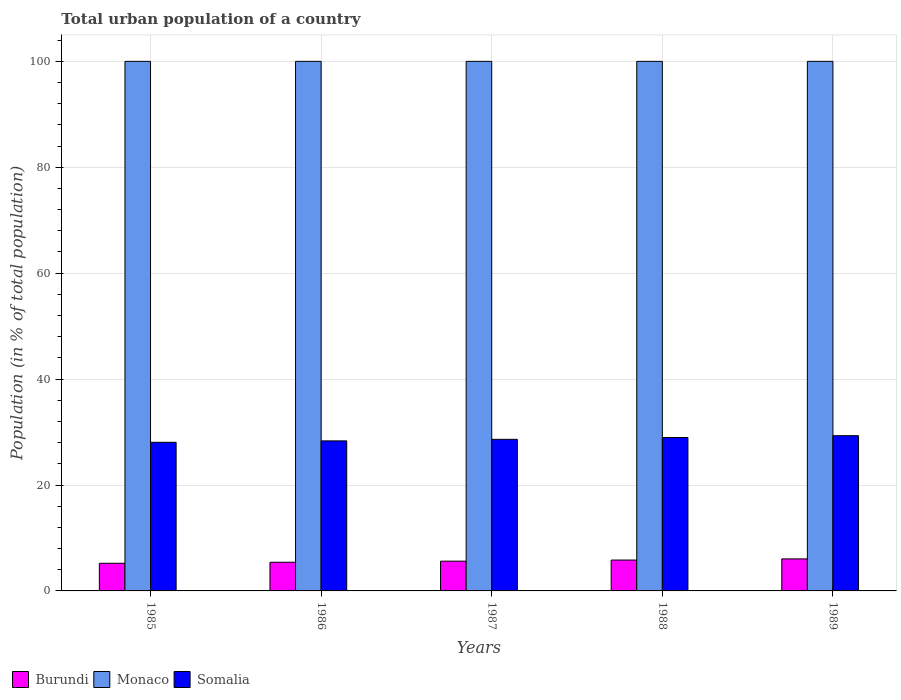Are the number of bars per tick equal to the number of legend labels?
Your answer should be very brief. Yes. Are the number of bars on each tick of the X-axis equal?
Keep it short and to the point. Yes. How many bars are there on the 1st tick from the left?
Ensure brevity in your answer.  3. How many bars are there on the 5th tick from the right?
Ensure brevity in your answer.  3. What is the label of the 1st group of bars from the left?
Make the answer very short. 1985. In how many cases, is the number of bars for a given year not equal to the number of legend labels?
Your answer should be compact. 0. What is the urban population in Monaco in 1989?
Offer a very short reply. 100. Across all years, what is the maximum urban population in Burundi?
Offer a very short reply. 6.05. Across all years, what is the minimum urban population in Monaco?
Ensure brevity in your answer.  100. What is the total urban population in Monaco in the graph?
Your response must be concise. 500. What is the difference between the urban population in Monaco in 1985 and that in 1989?
Provide a succinct answer. 0. What is the difference between the urban population in Somalia in 1986 and the urban population in Monaco in 1988?
Your answer should be very brief. -71.67. What is the average urban population in Somalia per year?
Your answer should be very brief. 28.66. In the year 1988, what is the difference between the urban population in Burundi and urban population in Monaco?
Your answer should be very brief. -94.17. In how many years, is the urban population in Monaco greater than 28 %?
Offer a terse response. 5. What is the ratio of the urban population in Burundi in 1988 to that in 1989?
Give a very brief answer. 0.96. Is the urban population in Monaco in 1987 less than that in 1989?
Give a very brief answer. No. What is the difference between the highest and the second highest urban population in Somalia?
Ensure brevity in your answer.  0.34. What is the difference between the highest and the lowest urban population in Burundi?
Keep it short and to the point. 0.83. Is the sum of the urban population in Somalia in 1985 and 1989 greater than the maximum urban population in Monaco across all years?
Make the answer very short. No. What does the 1st bar from the left in 1986 represents?
Your answer should be compact. Burundi. What does the 3rd bar from the right in 1985 represents?
Make the answer very short. Burundi. What is the difference between two consecutive major ticks on the Y-axis?
Provide a succinct answer. 20. Does the graph contain grids?
Give a very brief answer. Yes. How many legend labels are there?
Offer a terse response. 3. How are the legend labels stacked?
Make the answer very short. Horizontal. What is the title of the graph?
Provide a short and direct response. Total urban population of a country. Does "Northern Mariana Islands" appear as one of the legend labels in the graph?
Give a very brief answer. No. What is the label or title of the X-axis?
Your answer should be compact. Years. What is the label or title of the Y-axis?
Your answer should be very brief. Population (in % of total population). What is the Population (in % of total population) in Burundi in 1985?
Provide a succinct answer. 5.22. What is the Population (in % of total population) in Monaco in 1985?
Provide a succinct answer. 100. What is the Population (in % of total population) of Somalia in 1985?
Your response must be concise. 28.07. What is the Population (in % of total population) of Burundi in 1986?
Your answer should be compact. 5.42. What is the Population (in % of total population) in Somalia in 1986?
Provide a succinct answer. 28.33. What is the Population (in % of total population) of Burundi in 1987?
Offer a terse response. 5.62. What is the Population (in % of total population) of Monaco in 1987?
Offer a terse response. 100. What is the Population (in % of total population) in Somalia in 1987?
Keep it short and to the point. 28.63. What is the Population (in % of total population) in Burundi in 1988?
Provide a short and direct response. 5.83. What is the Population (in % of total population) in Monaco in 1988?
Your answer should be compact. 100. What is the Population (in % of total population) of Somalia in 1988?
Offer a terse response. 28.97. What is the Population (in % of total population) of Burundi in 1989?
Your answer should be very brief. 6.05. What is the Population (in % of total population) in Monaco in 1989?
Offer a terse response. 100. What is the Population (in % of total population) in Somalia in 1989?
Your response must be concise. 29.31. Across all years, what is the maximum Population (in % of total population) of Burundi?
Keep it short and to the point. 6.05. Across all years, what is the maximum Population (in % of total population) of Monaco?
Provide a short and direct response. 100. Across all years, what is the maximum Population (in % of total population) of Somalia?
Your response must be concise. 29.31. Across all years, what is the minimum Population (in % of total population) of Burundi?
Your answer should be very brief. 5.22. Across all years, what is the minimum Population (in % of total population) of Monaco?
Offer a very short reply. 100. Across all years, what is the minimum Population (in % of total population) of Somalia?
Make the answer very short. 28.07. What is the total Population (in % of total population) in Burundi in the graph?
Provide a succinct answer. 28.14. What is the total Population (in % of total population) of Monaco in the graph?
Offer a terse response. 500. What is the total Population (in % of total population) of Somalia in the graph?
Offer a very short reply. 143.31. What is the difference between the Population (in % of total population) in Burundi in 1985 and that in 1986?
Your answer should be very brief. -0.2. What is the difference between the Population (in % of total population) of Somalia in 1985 and that in 1986?
Your answer should be very brief. -0.27. What is the difference between the Population (in % of total population) of Burundi in 1985 and that in 1987?
Offer a very short reply. -0.4. What is the difference between the Population (in % of total population) in Somalia in 1985 and that in 1987?
Offer a terse response. -0.56. What is the difference between the Population (in % of total population) of Burundi in 1985 and that in 1988?
Offer a terse response. -0.61. What is the difference between the Population (in % of total population) in Somalia in 1985 and that in 1988?
Keep it short and to the point. -0.9. What is the difference between the Population (in % of total population) of Burundi in 1985 and that in 1989?
Make the answer very short. -0.83. What is the difference between the Population (in % of total population) of Monaco in 1985 and that in 1989?
Keep it short and to the point. 0. What is the difference between the Population (in % of total population) in Somalia in 1985 and that in 1989?
Offer a terse response. -1.25. What is the difference between the Population (in % of total population) of Burundi in 1986 and that in 1987?
Your answer should be very brief. -0.2. What is the difference between the Population (in % of total population) of Monaco in 1986 and that in 1987?
Provide a succinct answer. 0. What is the difference between the Population (in % of total population) of Somalia in 1986 and that in 1987?
Offer a very short reply. -0.29. What is the difference between the Population (in % of total population) in Burundi in 1986 and that in 1988?
Your answer should be very brief. -0.41. What is the difference between the Population (in % of total population) in Monaco in 1986 and that in 1988?
Make the answer very short. 0. What is the difference between the Population (in % of total population) in Somalia in 1986 and that in 1988?
Ensure brevity in your answer.  -0.64. What is the difference between the Population (in % of total population) in Burundi in 1986 and that in 1989?
Your response must be concise. -0.63. What is the difference between the Population (in % of total population) in Monaco in 1986 and that in 1989?
Your answer should be compact. 0. What is the difference between the Population (in % of total population) in Somalia in 1986 and that in 1989?
Offer a terse response. -0.98. What is the difference between the Population (in % of total population) of Burundi in 1987 and that in 1988?
Make the answer very short. -0.21. What is the difference between the Population (in % of total population) in Monaco in 1987 and that in 1988?
Provide a succinct answer. 0. What is the difference between the Population (in % of total population) in Somalia in 1987 and that in 1988?
Your response must be concise. -0.34. What is the difference between the Population (in % of total population) of Burundi in 1987 and that in 1989?
Offer a very short reply. -0.43. What is the difference between the Population (in % of total population) in Somalia in 1987 and that in 1989?
Your response must be concise. -0.69. What is the difference between the Population (in % of total population) of Burundi in 1988 and that in 1989?
Ensure brevity in your answer.  -0.22. What is the difference between the Population (in % of total population) of Somalia in 1988 and that in 1989?
Your answer should be compact. -0.34. What is the difference between the Population (in % of total population) in Burundi in 1985 and the Population (in % of total population) in Monaco in 1986?
Offer a terse response. -94.78. What is the difference between the Population (in % of total population) in Burundi in 1985 and the Population (in % of total population) in Somalia in 1986?
Your answer should be compact. -23.11. What is the difference between the Population (in % of total population) of Monaco in 1985 and the Population (in % of total population) of Somalia in 1986?
Your answer should be very brief. 71.67. What is the difference between the Population (in % of total population) of Burundi in 1985 and the Population (in % of total population) of Monaco in 1987?
Your answer should be compact. -94.78. What is the difference between the Population (in % of total population) in Burundi in 1985 and the Population (in % of total population) in Somalia in 1987?
Offer a very short reply. -23.41. What is the difference between the Population (in % of total population) of Monaco in 1985 and the Population (in % of total population) of Somalia in 1987?
Offer a very short reply. 71.37. What is the difference between the Population (in % of total population) in Burundi in 1985 and the Population (in % of total population) in Monaco in 1988?
Ensure brevity in your answer.  -94.78. What is the difference between the Population (in % of total population) in Burundi in 1985 and the Population (in % of total population) in Somalia in 1988?
Your answer should be very brief. -23.75. What is the difference between the Population (in % of total population) of Monaco in 1985 and the Population (in % of total population) of Somalia in 1988?
Your answer should be very brief. 71.03. What is the difference between the Population (in % of total population) of Burundi in 1985 and the Population (in % of total population) of Monaco in 1989?
Keep it short and to the point. -94.78. What is the difference between the Population (in % of total population) of Burundi in 1985 and the Population (in % of total population) of Somalia in 1989?
Give a very brief answer. -24.09. What is the difference between the Population (in % of total population) of Monaco in 1985 and the Population (in % of total population) of Somalia in 1989?
Offer a very short reply. 70.69. What is the difference between the Population (in % of total population) in Burundi in 1986 and the Population (in % of total population) in Monaco in 1987?
Offer a very short reply. -94.58. What is the difference between the Population (in % of total population) in Burundi in 1986 and the Population (in % of total population) in Somalia in 1987?
Provide a succinct answer. -23.21. What is the difference between the Population (in % of total population) of Monaco in 1986 and the Population (in % of total population) of Somalia in 1987?
Make the answer very short. 71.37. What is the difference between the Population (in % of total population) in Burundi in 1986 and the Population (in % of total population) in Monaco in 1988?
Offer a terse response. -94.58. What is the difference between the Population (in % of total population) of Burundi in 1986 and the Population (in % of total population) of Somalia in 1988?
Offer a very short reply. -23.55. What is the difference between the Population (in % of total population) in Monaco in 1986 and the Population (in % of total population) in Somalia in 1988?
Offer a very short reply. 71.03. What is the difference between the Population (in % of total population) of Burundi in 1986 and the Population (in % of total population) of Monaco in 1989?
Your response must be concise. -94.58. What is the difference between the Population (in % of total population) in Burundi in 1986 and the Population (in % of total population) in Somalia in 1989?
Provide a short and direct response. -23.89. What is the difference between the Population (in % of total population) of Monaco in 1986 and the Population (in % of total population) of Somalia in 1989?
Offer a terse response. 70.69. What is the difference between the Population (in % of total population) in Burundi in 1987 and the Population (in % of total population) in Monaco in 1988?
Your response must be concise. -94.38. What is the difference between the Population (in % of total population) in Burundi in 1987 and the Population (in % of total population) in Somalia in 1988?
Ensure brevity in your answer.  -23.35. What is the difference between the Population (in % of total population) of Monaco in 1987 and the Population (in % of total population) of Somalia in 1988?
Your answer should be compact. 71.03. What is the difference between the Population (in % of total population) in Burundi in 1987 and the Population (in % of total population) in Monaco in 1989?
Offer a very short reply. -94.38. What is the difference between the Population (in % of total population) in Burundi in 1987 and the Population (in % of total population) in Somalia in 1989?
Provide a short and direct response. -23.69. What is the difference between the Population (in % of total population) in Monaco in 1987 and the Population (in % of total population) in Somalia in 1989?
Your answer should be very brief. 70.69. What is the difference between the Population (in % of total population) in Burundi in 1988 and the Population (in % of total population) in Monaco in 1989?
Your answer should be very brief. -94.17. What is the difference between the Population (in % of total population) in Burundi in 1988 and the Population (in % of total population) in Somalia in 1989?
Your response must be concise. -23.48. What is the difference between the Population (in % of total population) in Monaco in 1988 and the Population (in % of total population) in Somalia in 1989?
Offer a very short reply. 70.69. What is the average Population (in % of total population) in Burundi per year?
Provide a succinct answer. 5.63. What is the average Population (in % of total population) in Somalia per year?
Ensure brevity in your answer.  28.66. In the year 1985, what is the difference between the Population (in % of total population) in Burundi and Population (in % of total population) in Monaco?
Give a very brief answer. -94.78. In the year 1985, what is the difference between the Population (in % of total population) in Burundi and Population (in % of total population) in Somalia?
Give a very brief answer. -22.85. In the year 1985, what is the difference between the Population (in % of total population) of Monaco and Population (in % of total population) of Somalia?
Make the answer very short. 71.93. In the year 1986, what is the difference between the Population (in % of total population) in Burundi and Population (in % of total population) in Monaco?
Provide a short and direct response. -94.58. In the year 1986, what is the difference between the Population (in % of total population) in Burundi and Population (in % of total population) in Somalia?
Your response must be concise. -22.92. In the year 1986, what is the difference between the Population (in % of total population) of Monaco and Population (in % of total population) of Somalia?
Give a very brief answer. 71.67. In the year 1987, what is the difference between the Population (in % of total population) in Burundi and Population (in % of total population) in Monaco?
Keep it short and to the point. -94.38. In the year 1987, what is the difference between the Population (in % of total population) in Burundi and Population (in % of total population) in Somalia?
Provide a succinct answer. -23.01. In the year 1987, what is the difference between the Population (in % of total population) of Monaco and Population (in % of total population) of Somalia?
Make the answer very short. 71.37. In the year 1988, what is the difference between the Population (in % of total population) of Burundi and Population (in % of total population) of Monaco?
Your answer should be very brief. -94.17. In the year 1988, what is the difference between the Population (in % of total population) in Burundi and Population (in % of total population) in Somalia?
Ensure brevity in your answer.  -23.14. In the year 1988, what is the difference between the Population (in % of total population) in Monaco and Population (in % of total population) in Somalia?
Provide a succinct answer. 71.03. In the year 1989, what is the difference between the Population (in % of total population) in Burundi and Population (in % of total population) in Monaco?
Provide a succinct answer. -93.95. In the year 1989, what is the difference between the Population (in % of total population) of Burundi and Population (in % of total population) of Somalia?
Your response must be concise. -23.27. In the year 1989, what is the difference between the Population (in % of total population) in Monaco and Population (in % of total population) in Somalia?
Make the answer very short. 70.69. What is the ratio of the Population (in % of total population) in Burundi in 1985 to that in 1986?
Offer a terse response. 0.96. What is the ratio of the Population (in % of total population) in Monaco in 1985 to that in 1986?
Keep it short and to the point. 1. What is the ratio of the Population (in % of total population) in Somalia in 1985 to that in 1986?
Your answer should be compact. 0.99. What is the ratio of the Population (in % of total population) in Burundi in 1985 to that in 1987?
Offer a very short reply. 0.93. What is the ratio of the Population (in % of total population) in Somalia in 1985 to that in 1987?
Offer a terse response. 0.98. What is the ratio of the Population (in % of total population) of Burundi in 1985 to that in 1988?
Your answer should be very brief. 0.9. What is the ratio of the Population (in % of total population) in Monaco in 1985 to that in 1988?
Your answer should be very brief. 1. What is the ratio of the Population (in % of total population) in Somalia in 1985 to that in 1988?
Make the answer very short. 0.97. What is the ratio of the Population (in % of total population) in Burundi in 1985 to that in 1989?
Your answer should be compact. 0.86. What is the ratio of the Population (in % of total population) in Somalia in 1985 to that in 1989?
Provide a short and direct response. 0.96. What is the ratio of the Population (in % of total population) of Burundi in 1986 to that in 1987?
Make the answer very short. 0.96. What is the ratio of the Population (in % of total population) of Somalia in 1986 to that in 1987?
Your answer should be compact. 0.99. What is the ratio of the Population (in % of total population) of Burundi in 1986 to that in 1988?
Ensure brevity in your answer.  0.93. What is the ratio of the Population (in % of total population) in Monaco in 1986 to that in 1988?
Provide a succinct answer. 1. What is the ratio of the Population (in % of total population) of Burundi in 1986 to that in 1989?
Your answer should be very brief. 0.9. What is the ratio of the Population (in % of total population) of Monaco in 1986 to that in 1989?
Keep it short and to the point. 1. What is the ratio of the Population (in % of total population) in Somalia in 1986 to that in 1989?
Your answer should be very brief. 0.97. What is the ratio of the Population (in % of total population) of Monaco in 1987 to that in 1988?
Your answer should be compact. 1. What is the ratio of the Population (in % of total population) of Burundi in 1987 to that in 1989?
Your answer should be compact. 0.93. What is the ratio of the Population (in % of total population) in Somalia in 1987 to that in 1989?
Your answer should be very brief. 0.98. What is the ratio of the Population (in % of total population) of Burundi in 1988 to that in 1989?
Offer a terse response. 0.96. What is the ratio of the Population (in % of total population) of Monaco in 1988 to that in 1989?
Give a very brief answer. 1. What is the ratio of the Population (in % of total population) in Somalia in 1988 to that in 1989?
Offer a very short reply. 0.99. What is the difference between the highest and the second highest Population (in % of total population) of Burundi?
Make the answer very short. 0.22. What is the difference between the highest and the second highest Population (in % of total population) in Monaco?
Ensure brevity in your answer.  0. What is the difference between the highest and the second highest Population (in % of total population) in Somalia?
Your response must be concise. 0.34. What is the difference between the highest and the lowest Population (in % of total population) in Burundi?
Give a very brief answer. 0.83. What is the difference between the highest and the lowest Population (in % of total population) in Monaco?
Ensure brevity in your answer.  0. What is the difference between the highest and the lowest Population (in % of total population) of Somalia?
Your answer should be very brief. 1.25. 